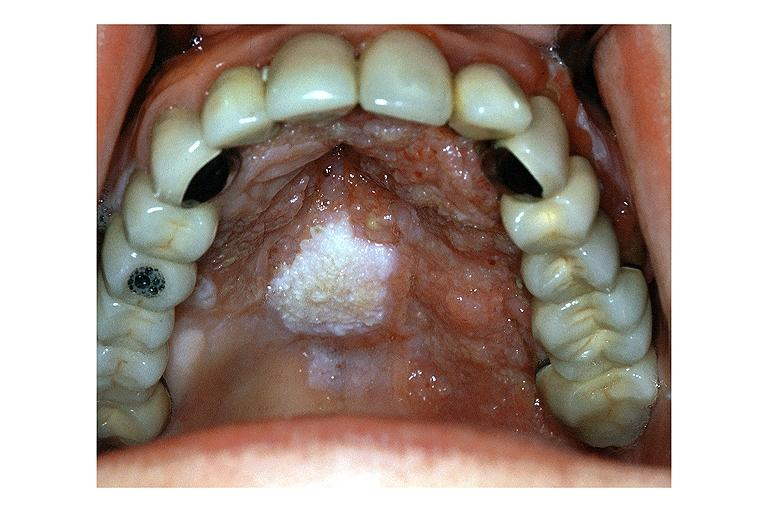what does this image show?
Answer the question using a single word or phrase. Verrucous carcinoma 